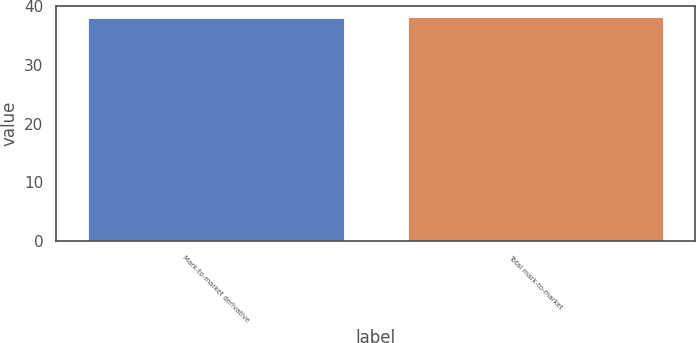Convert chart to OTSL. <chart><loc_0><loc_0><loc_500><loc_500><bar_chart><fcel>Mark-to-market derivative<fcel>Total mark-to-market<nl><fcel>38<fcel>38.1<nl></chart> 